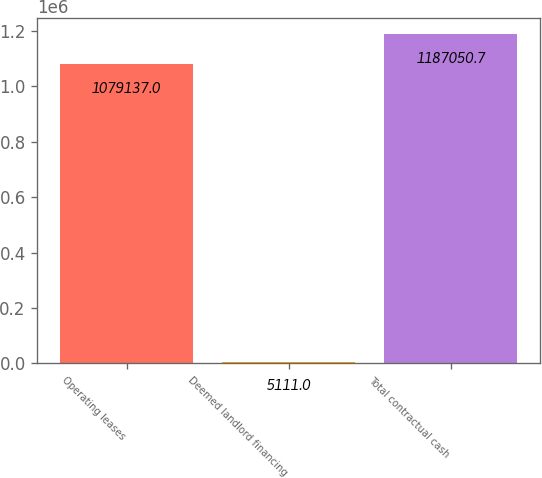Convert chart. <chart><loc_0><loc_0><loc_500><loc_500><bar_chart><fcel>Operating leases<fcel>Deemed landlord financing<fcel>Total contractual cash<nl><fcel>1.07914e+06<fcel>5111<fcel>1.18705e+06<nl></chart> 